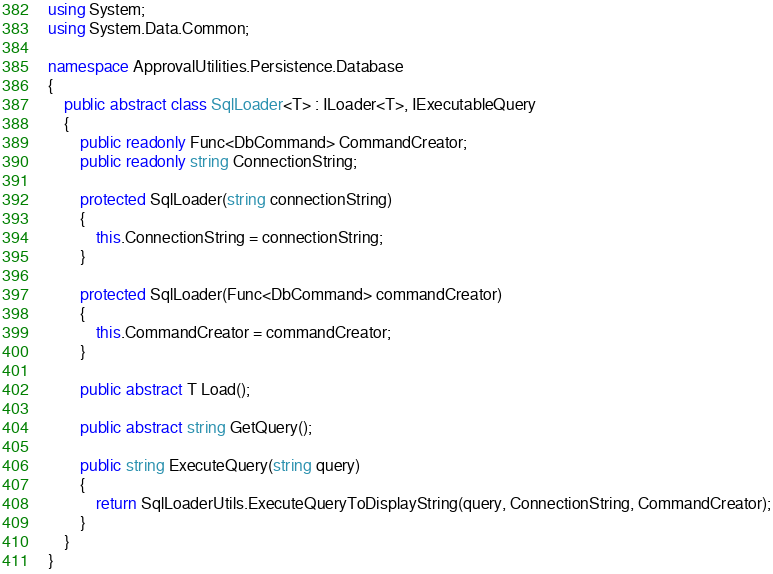<code> <loc_0><loc_0><loc_500><loc_500><_C#_>using System;
using System.Data.Common;

namespace ApprovalUtilities.Persistence.Database
{
	public abstract class SqlLoader<T> : ILoader<T>, IExecutableQuery
	{
		public readonly Func<DbCommand> CommandCreator;
		public readonly string ConnectionString;

		protected SqlLoader(string connectionString)
		{
			this.ConnectionString = connectionString;
		}

		protected SqlLoader(Func<DbCommand> commandCreator)
		{
			this.CommandCreator = commandCreator;
		}

		public abstract T Load();

		public abstract string GetQuery();

		public string ExecuteQuery(string query)
		{
			return SqlLoaderUtils.ExecuteQueryToDisplayString(query, ConnectionString, CommandCreator);
		}
	}
}</code> 